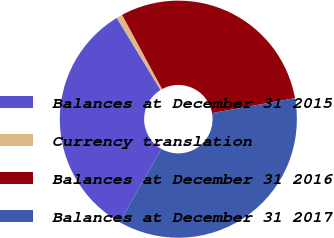Convert chart. <chart><loc_0><loc_0><loc_500><loc_500><pie_chart><fcel>Balances at December 31 2015<fcel>Currency translation<fcel>Balances at December 31 2016<fcel>Balances at December 31 2017<nl><fcel>33.06%<fcel>0.83%<fcel>30.03%<fcel>36.09%<nl></chart> 